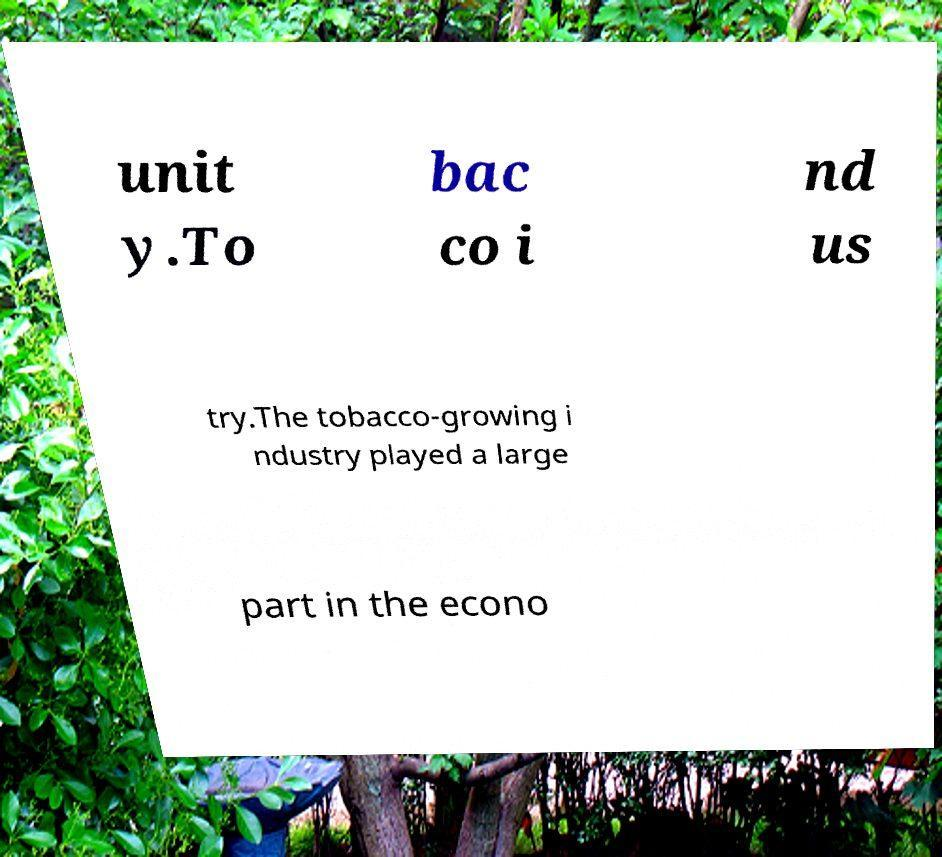For documentation purposes, I need the text within this image transcribed. Could you provide that? unit y.To bac co i nd us try.The tobacco-growing i ndustry played a large part in the econo 